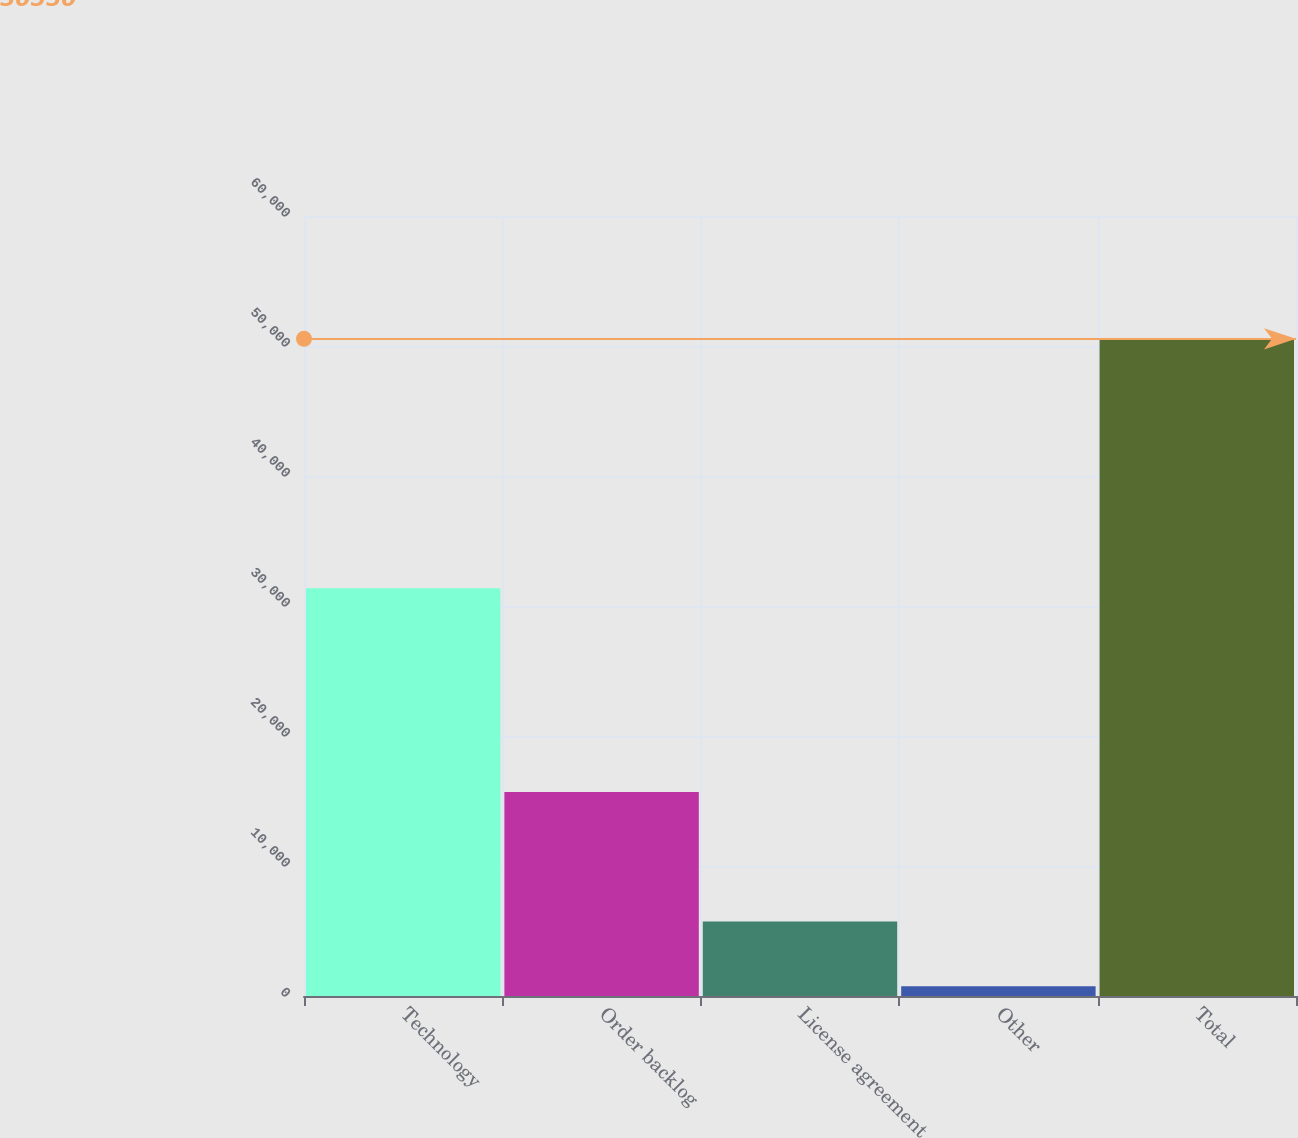<chart> <loc_0><loc_0><loc_500><loc_500><bar_chart><fcel>Technology<fcel>Order backlog<fcel>License agreement<fcel>Other<fcel>Total<nl><fcel>31369<fcel>15698<fcel>5722.8<fcel>742<fcel>50550<nl></chart> 